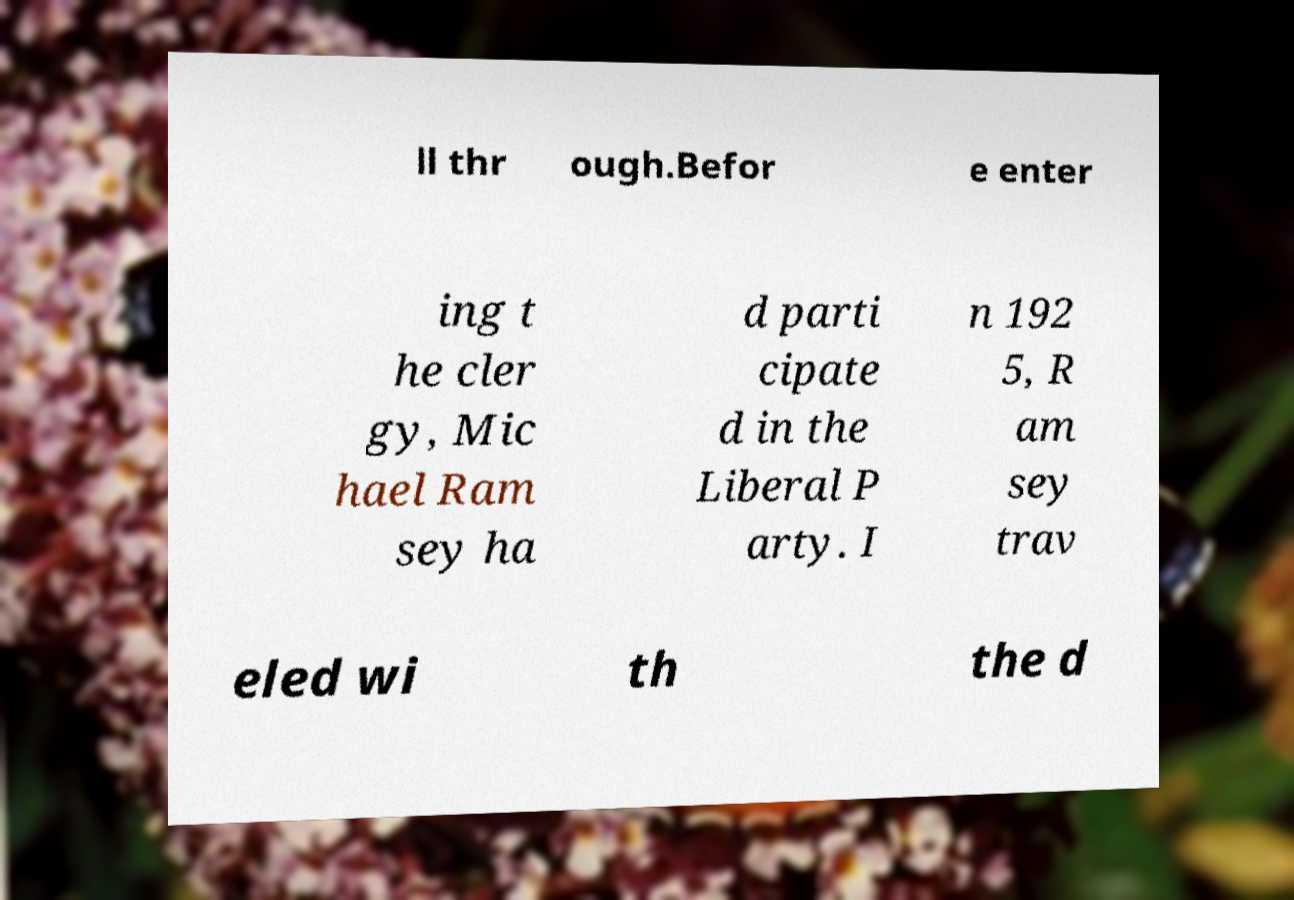Please read and relay the text visible in this image. What does it say? ll thr ough.Befor e enter ing t he cler gy, Mic hael Ram sey ha d parti cipate d in the Liberal P arty. I n 192 5, R am sey trav eled wi th the d 